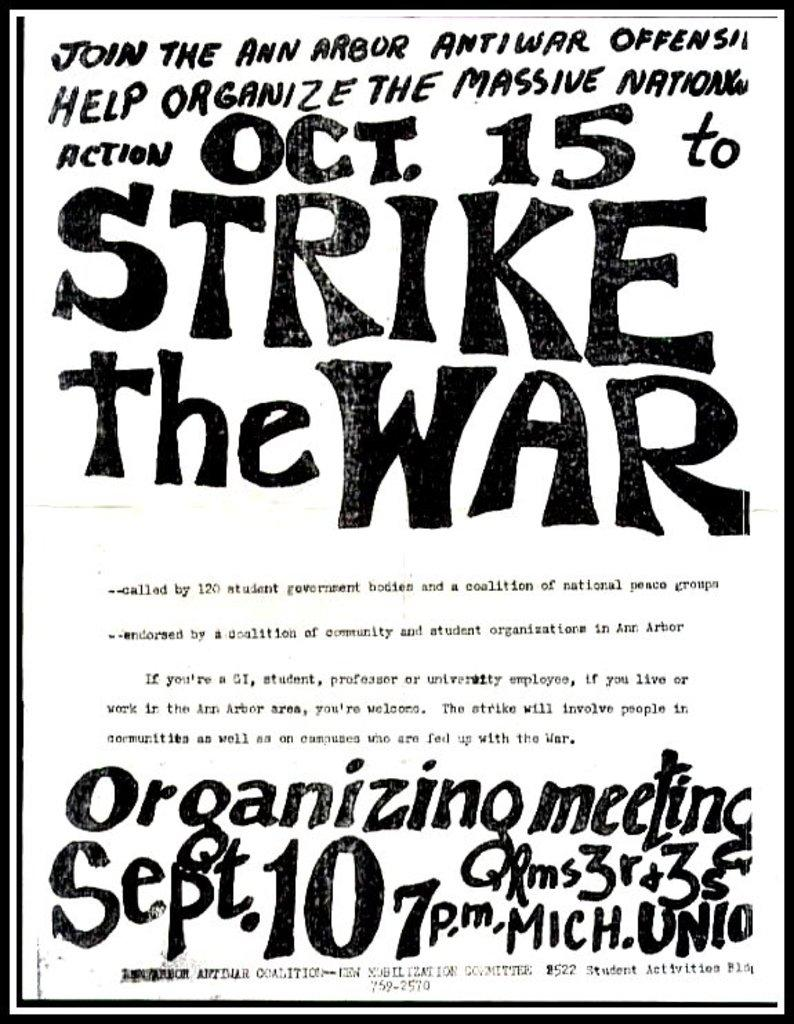<image>
Share a concise interpretation of the image provided. A flyer to join the STRIKE THE WAR action on October 15 